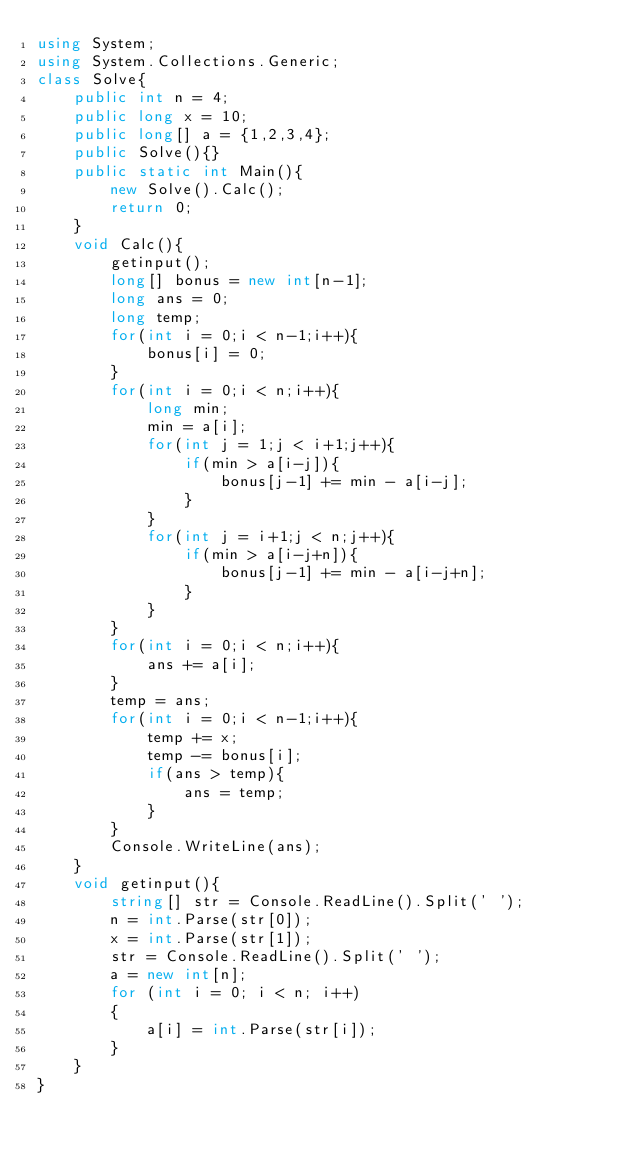<code> <loc_0><loc_0><loc_500><loc_500><_C#_>using System;
using System.Collections.Generic;
class Solve{
    public int n = 4;
    public long x = 10;
    public long[] a = {1,2,3,4};
    public Solve(){}
    public static int Main(){
        new Solve().Calc();
        return 0;
    }
    void Calc(){
        getinput();
        long[] bonus = new int[n-1];
        long ans = 0;
        long temp;
        for(int i = 0;i < n-1;i++){
            bonus[i] = 0;
        }
        for(int i = 0;i < n;i++){
            long min;
            min = a[i];
            for(int j = 1;j < i+1;j++){
                if(min > a[i-j]){
                    bonus[j-1] += min - a[i-j];
                }
            }
            for(int j = i+1;j < n;j++){
                if(min > a[i-j+n]){
                    bonus[j-1] += min - a[i-j+n];
                }
            }
        }
        for(int i = 0;i < n;i++){
            ans += a[i];
        }
        temp = ans;
        for(int i = 0;i < n-1;i++){
            temp += x;
            temp -= bonus[i];
            if(ans > temp){
                ans = temp;
            }
        }
        Console.WriteLine(ans);
    }
    void getinput(){
        string[] str = Console.ReadLine().Split(' ');
        n = int.Parse(str[0]);
        x = int.Parse(str[1]);
        str = Console.ReadLine().Split(' ');
        a = new int[n];
        for (int i = 0; i < n; i++)
        {
            a[i] = int.Parse(str[i]);
        }
    }    
}</code> 